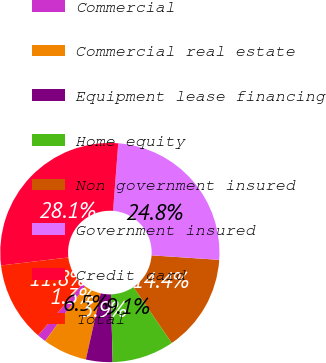<chart> <loc_0><loc_0><loc_500><loc_500><pie_chart><fcel>Commercial<fcel>Commercial real estate<fcel>Equipment lease financing<fcel>Home equity<fcel>Non government insured<fcel>Government insured<fcel>Credit card<fcel>Total<nl><fcel>1.31%<fcel>6.54%<fcel>3.92%<fcel>9.15%<fcel>14.38%<fcel>24.84%<fcel>28.1%<fcel>11.76%<nl></chart> 